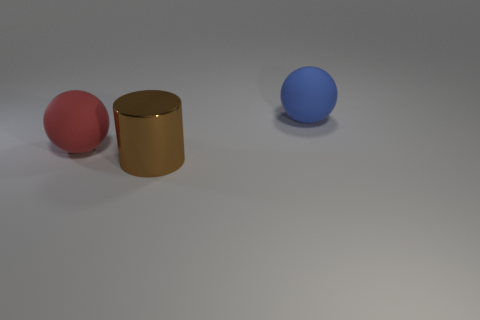Add 2 blocks. How many objects exist? 5 Subtract all cylinders. How many objects are left? 2 Subtract all tiny brown blocks. Subtract all big blue rubber objects. How many objects are left? 2 Add 3 big matte balls. How many big matte balls are left? 5 Add 2 gray matte spheres. How many gray matte spheres exist? 2 Subtract 0 blue cubes. How many objects are left? 3 